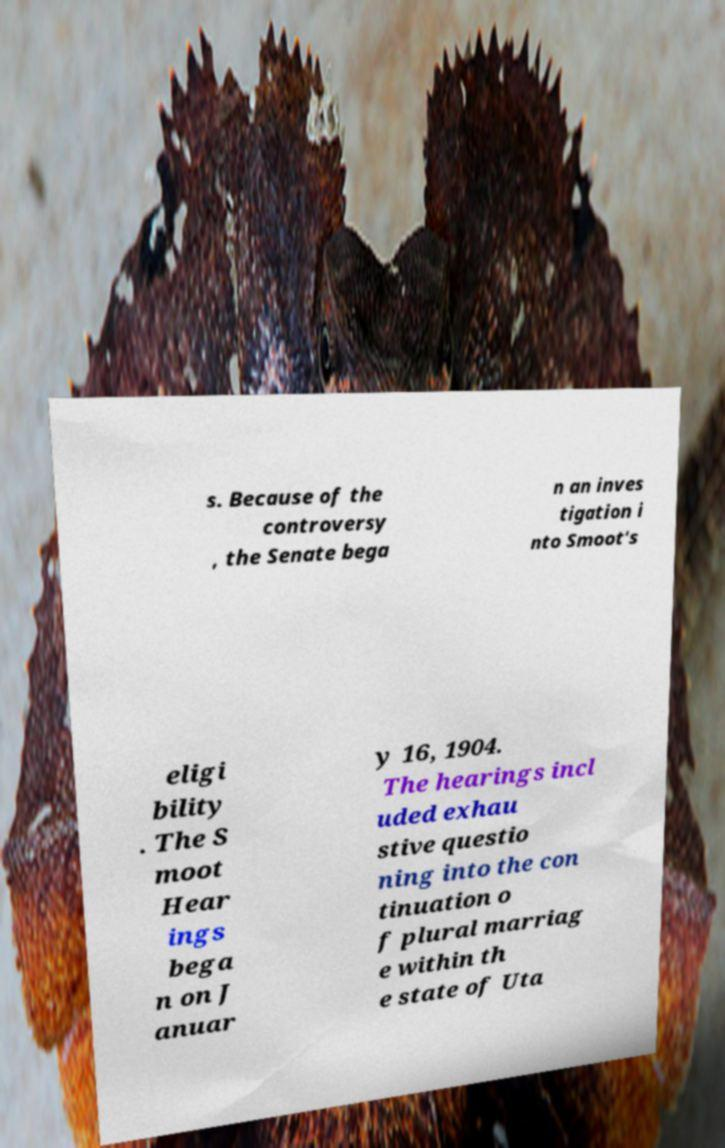Can you read and provide the text displayed in the image?This photo seems to have some interesting text. Can you extract and type it out for me? s. Because of the controversy , the Senate bega n an inves tigation i nto Smoot's eligi bility . The S moot Hear ings bega n on J anuar y 16, 1904. The hearings incl uded exhau stive questio ning into the con tinuation o f plural marriag e within th e state of Uta 